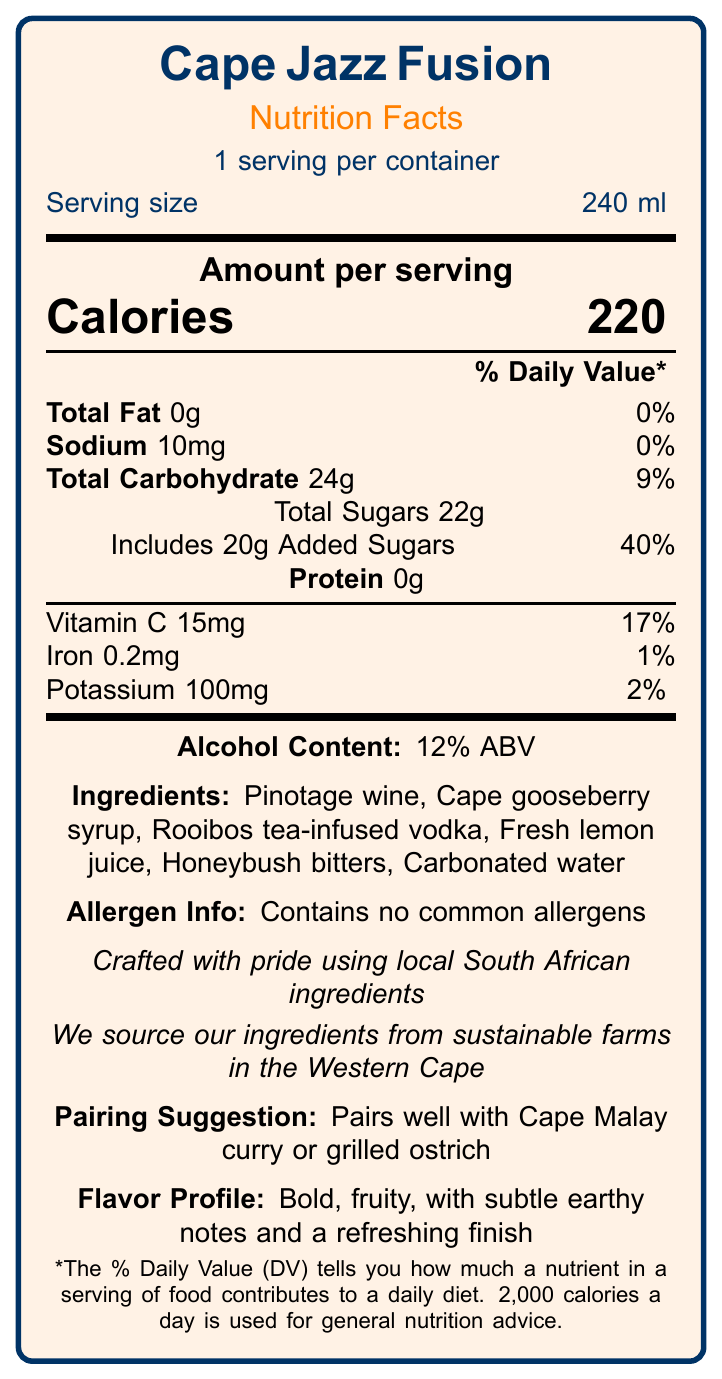What is the serving size of Cape Jazz Fusion? The document states the serving size as "240 ml."
Answer: 240 ml How many servings are there per container of Cape Jazz Fusion? It mentions "1 serving per container."
Answer: 1 How many calories are in one serving of Cape Jazz Fusion? The document lists the calories per serving as 220.
Answer: 220 What is the total carbohydrate content in one serving? The total carbohydrate content is indicated as 24g.
Answer: 24g What percentage of the daily value of added sugars does Cape Jazz Fusion provide? It states that the added sugars amount to 20g, which is 40% of the daily value.
Answer: 40% What is the alcohol content of Cape Jazz Fusion? The alcohol content is mentioned as 12% ABV.
Answer: 12% ABV Which of the following ingredients is NOT listed in Cape Jazz Fusion? A. Cape gooseberry syrup B. Fresh lemon juice C. Almond extract D. Rooibos tea-infused vodka The ingredients list includes Cape gooseberry syrup, Fresh lemon juice, and Rooibos tea-infused vodka, but not Almond extract.
Answer: C. Almond extract How much sodium is in one serving, and what is its daily value percentage? The sodium content is 10mg, which is 0% of the daily value.
Answer: 10mg, 0% Does Cape Jazz Fusion contain any common allergens? The allergen information states that it contains no common allergens.
Answer: No What are the suggested food pairings for Cape Jazz Fusion? The pairing suggestion section recommends Cape Malay curry or grilled ostrich.
Answer: Cape Malay curry or grilled ostrich. True or False: Cape Jazz Fusion is crafted using only imported ingredients. The origin statement says it is crafted using local South African ingredients.
Answer: False What is the flavor profile of Cape Jazz Fusion? A. Light, citrusy, with a dry finish B. Bold, fruity, with subtle earthy notes and a refreshing finish C. Sweet, spicy, with hints of vanilla D. Smooth, creamy, with a touch of caramel It explicitly mentions the flavor profile as "Bold, fruity, with subtle earthy notes and a refreshing finish."
Answer: B. Bold, fruity, with subtle earthy notes and a refreshing finish Why might someone choose Cape Jazz Fusion over another cocktail? The sustainability note mentions sourcing from sustainable farms, and it has local flavor pairings.
Answer: Because it is made with sustainable, local ingredients and pairs well with local cuisine. How much protein does Cape Jazz Fusion contain? The protein content is listed as 0g.
Answer: 0g Describe the main idea of the document. The document provides a comprehensive overview of the Cape Jazz Fusion cocktail, including detailed nutritional information and associated notes on ingredients, sustainability, and suggested pairings.
Answer: The document is a detailed Nutrition Facts Label for a popular South African jazz-inspired cocktail called Cape Jazz Fusion. It highlights the serving size, calorie content, nutritional information, ingredients, allergen information, origin statement, sustainability note, pairing suggestion, and flavor profile. What are the servings per pack for Cape Jazz Fusion? The document provides "servings per container: 1" but does not provide information on the number of packs. Therefore, the number of servings per pack is not determinable.
Answer: Not enough information 